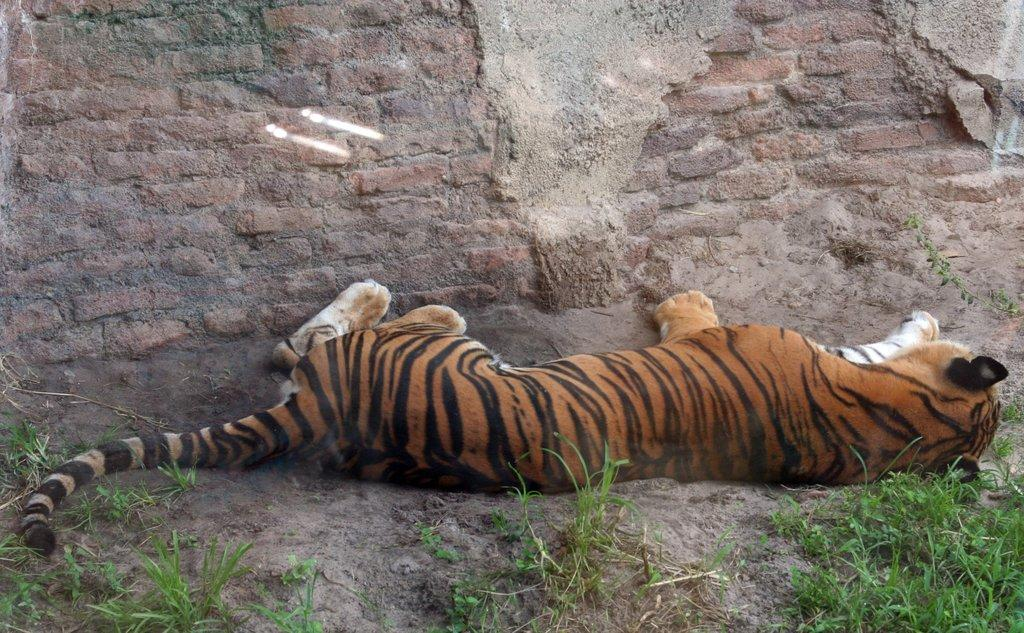What animal is lying on the ground in the image? There is a tiger lying on the ground in the image. What type of vegetation can be seen in the image? There is grass visible in the image. What type of structure is visible in the background of the image? There is a brick wall in the background of the image. What type of appliance is hanging from the tiger's neck in the image? There is no appliance present in the image, and the tiger is not wearing anything around its neck. 